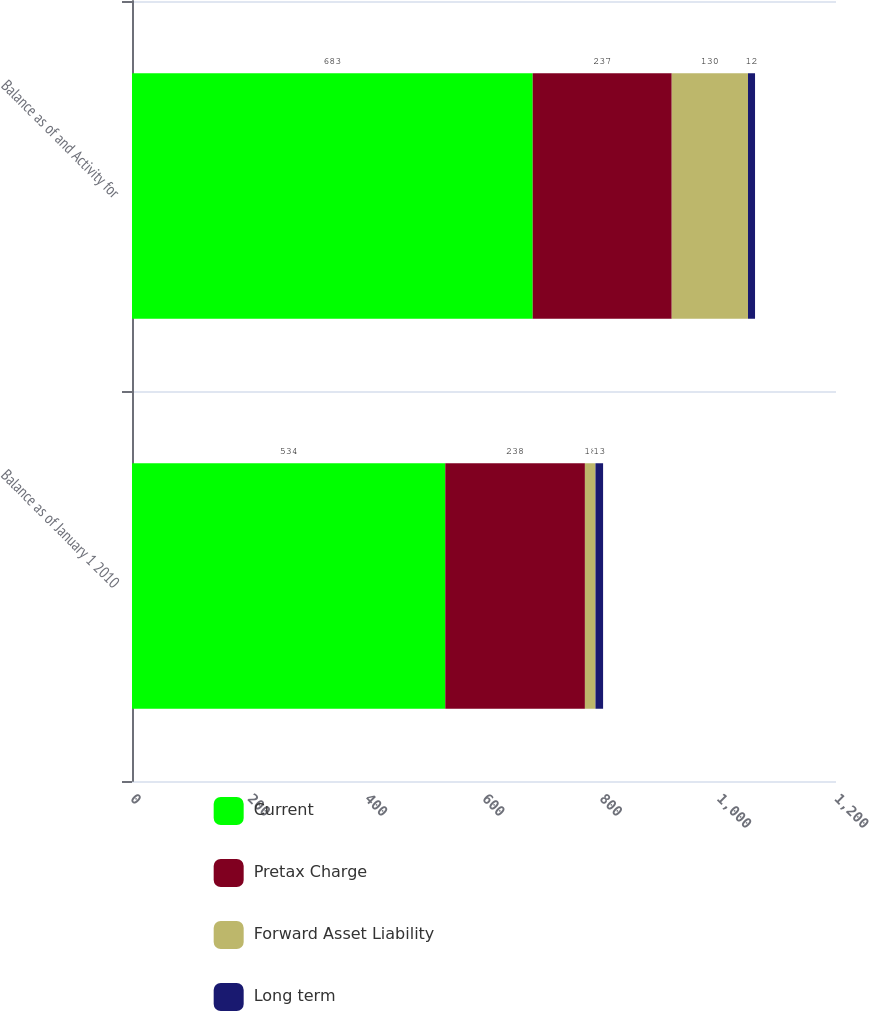Convert chart. <chart><loc_0><loc_0><loc_500><loc_500><stacked_bar_chart><ecel><fcel>Balance as of January 1 2010<fcel>Balance as of and Activity for<nl><fcel>Current<fcel>534<fcel>683<nl><fcel>Pretax Charge<fcel>238<fcel>237<nl><fcel>Forward Asset Liability<fcel>18<fcel>130<nl><fcel>Long term<fcel>13<fcel>12<nl></chart> 